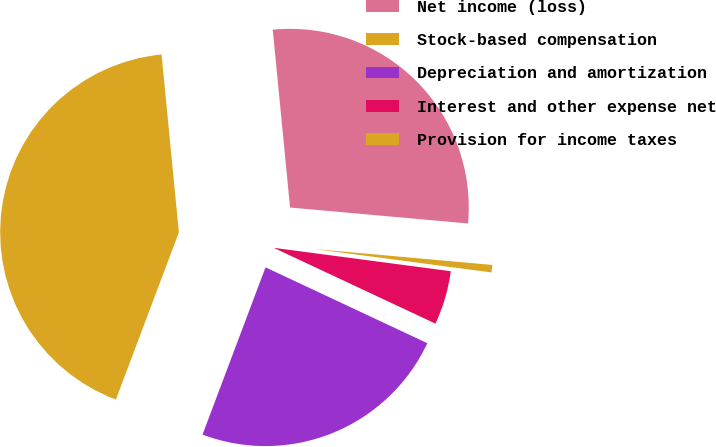<chart> <loc_0><loc_0><loc_500><loc_500><pie_chart><fcel>Net income (loss)<fcel>Stock-based compensation<fcel>Depreciation and amortization<fcel>Interest and other expense net<fcel>Provision for income taxes<nl><fcel>27.97%<fcel>42.72%<fcel>23.76%<fcel>4.88%<fcel>0.67%<nl></chart> 